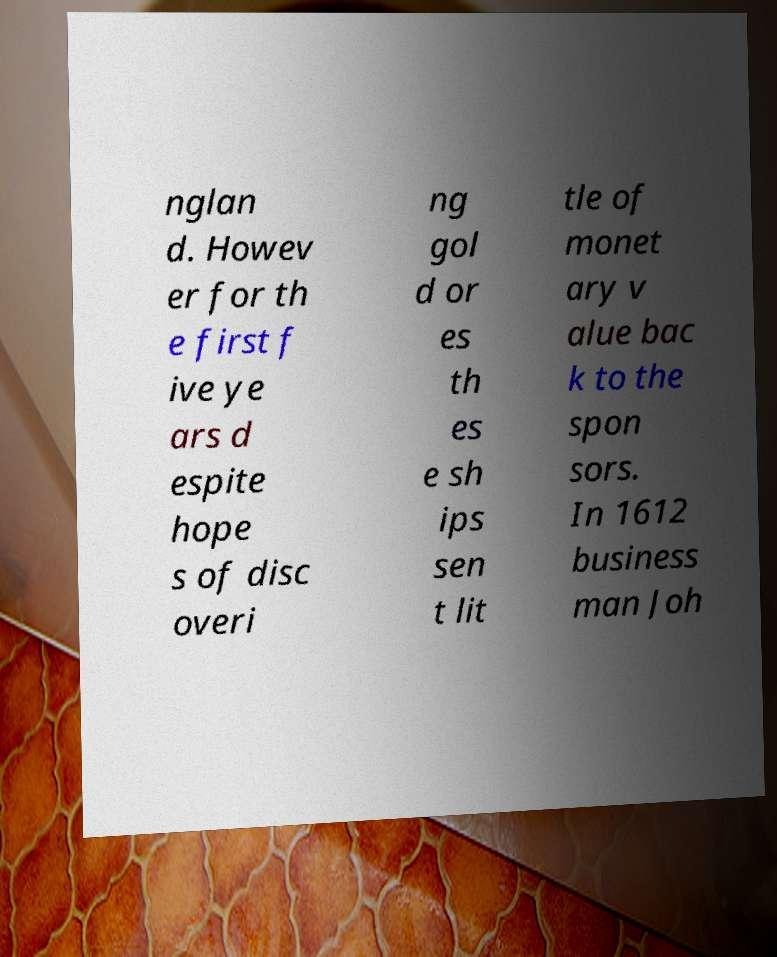Please read and relay the text visible in this image. What does it say? nglan d. Howev er for th e first f ive ye ars d espite hope s of disc overi ng gol d or es th es e sh ips sen t lit tle of monet ary v alue bac k to the spon sors. In 1612 business man Joh 